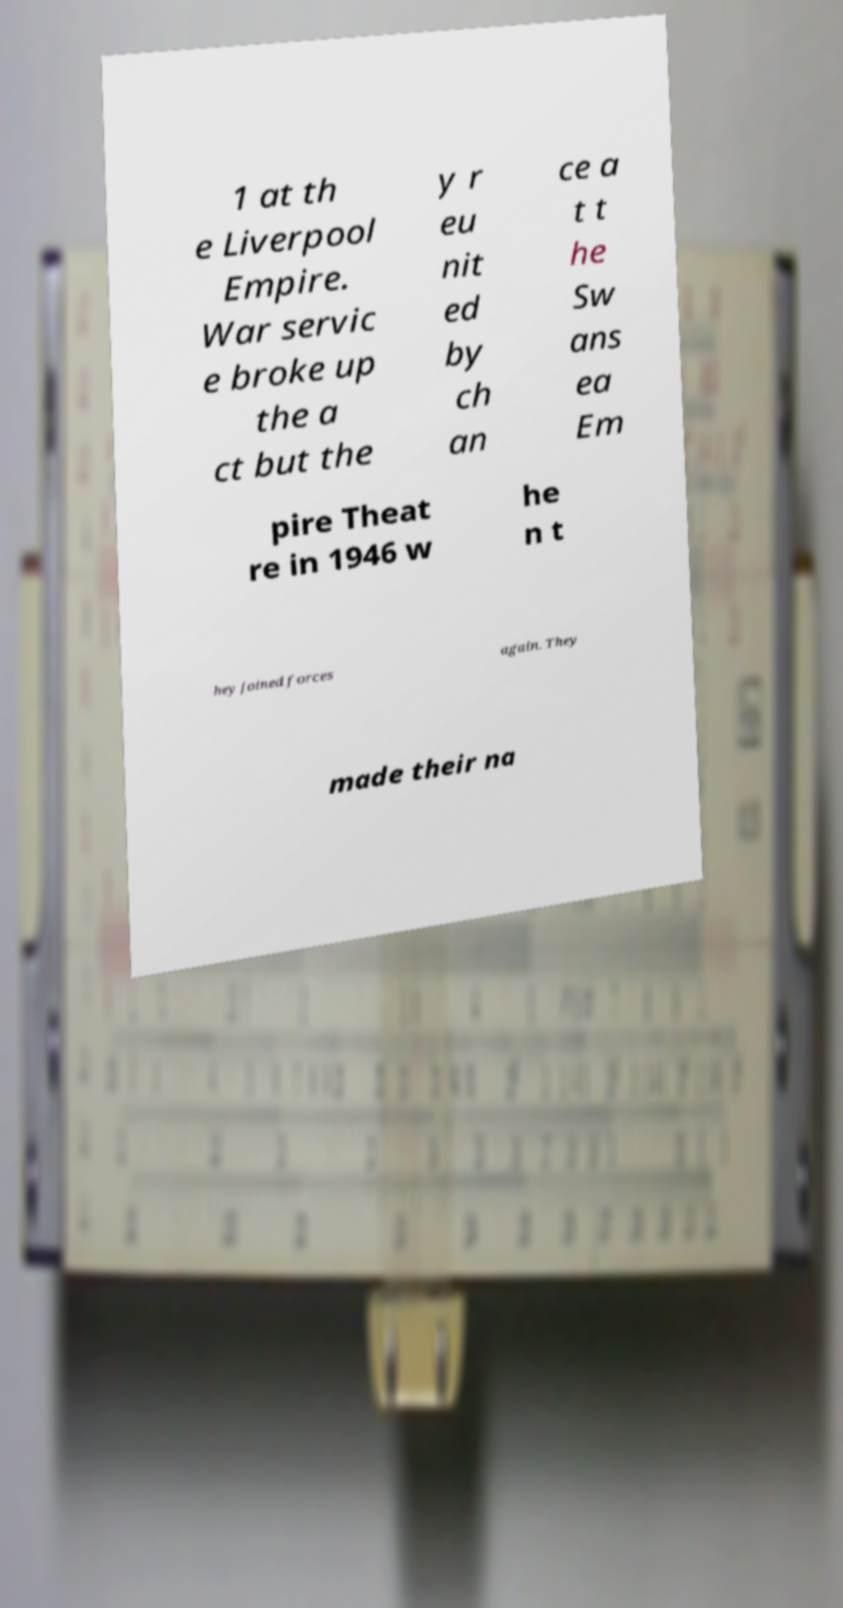I need the written content from this picture converted into text. Can you do that? 1 at th e Liverpool Empire. War servic e broke up the a ct but the y r eu nit ed by ch an ce a t t he Sw ans ea Em pire Theat re in 1946 w he n t hey joined forces again. They made their na 